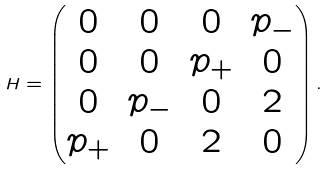Convert formula to latex. <formula><loc_0><loc_0><loc_500><loc_500>H = \begin{pmatrix} 0 & 0 & 0 & p _ { - } \\ 0 & 0 & p _ { + } & 0 \\ 0 & p _ { - } & 0 & 2 \\ p _ { + } & 0 & 2 & 0 \\ \end{pmatrix} .</formula> 